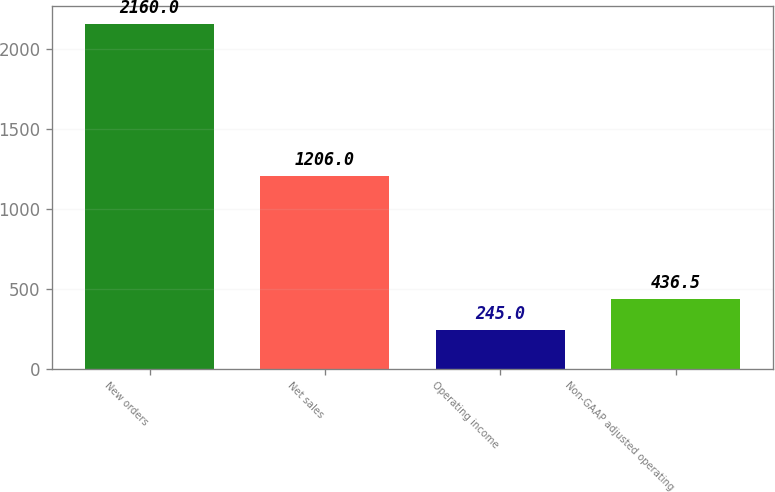Convert chart. <chart><loc_0><loc_0><loc_500><loc_500><bar_chart><fcel>New orders<fcel>Net sales<fcel>Operating income<fcel>Non-GAAP adjusted operating<nl><fcel>2160<fcel>1206<fcel>245<fcel>436.5<nl></chart> 